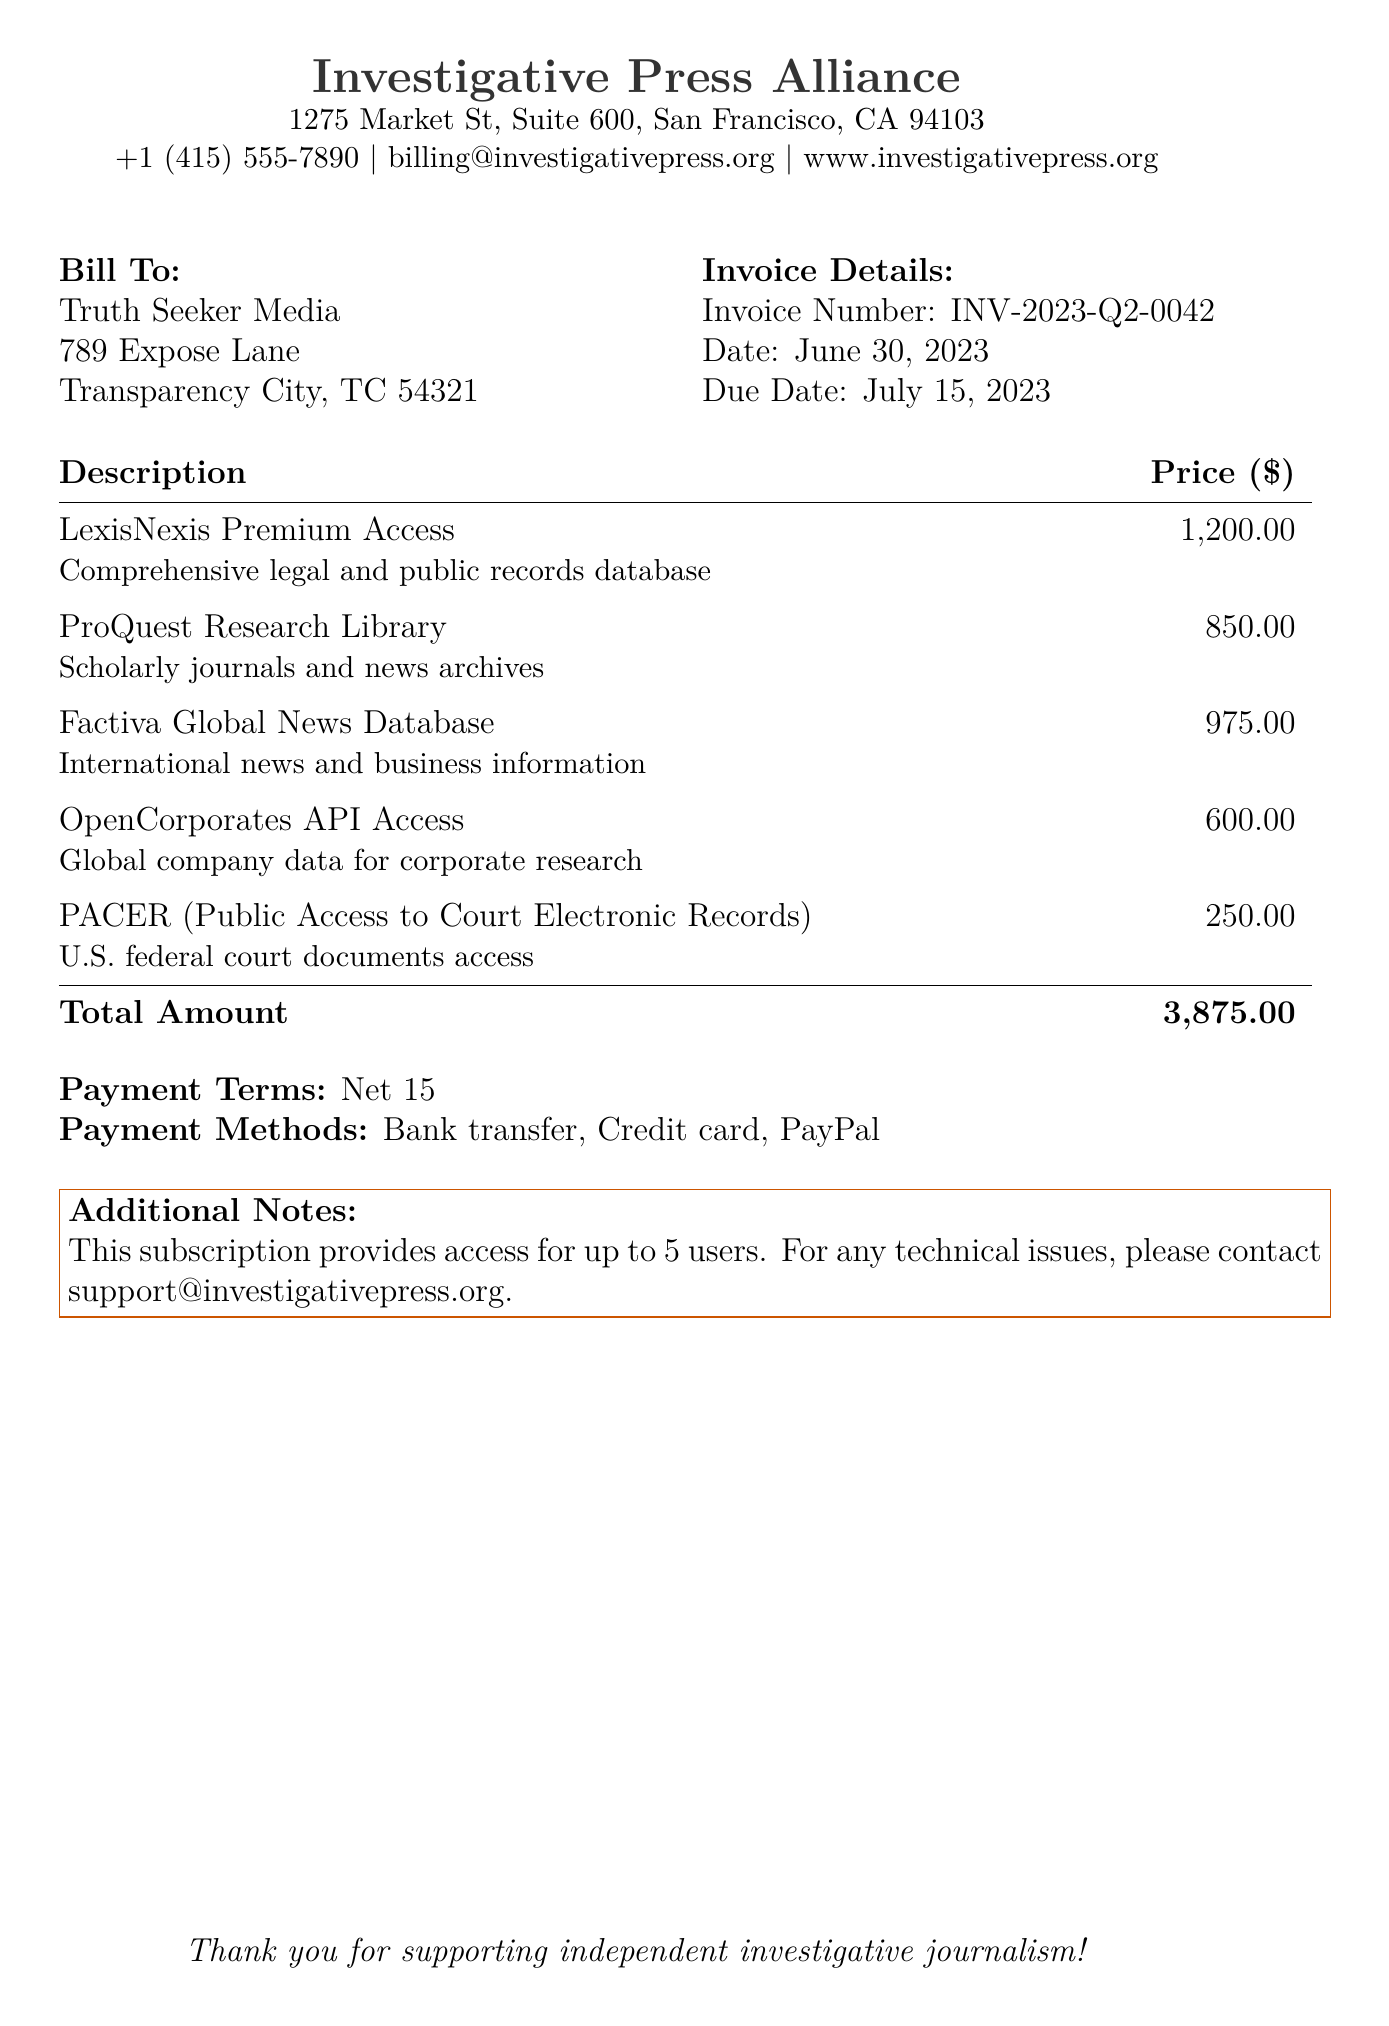What is the total amount due? The total amount due is specified in the invoice as the total of all services listed.
Answer: 3,875.00 What is the invoice number? The invoice number identifies this particular bill for tracking purposes.
Answer: INV-2023-Q2-0042 What is the due date for the payment? The due date indicates when the payment should be made to avoid any penalties.
Answer: July 15, 2023 How many users can access the subscription? This indicates the number of users that can utilize the services provided under this subscription.
Answer: 5 What is the payment term? This specifies the payment condition that must be met.
Answer: Net 15 Which service has the highest price? This identifies the most expensive service listed in the invoice.
Answer: LexisNexis Premium Access What is the price of the OpenCorporates API Access? This directly asks for the price of a specific service included in the invoice.
Answer: 600.00 What payment methods are available? This question asks for the options provided for making the payment.
Answer: Bank transfer, Credit card, PayPal What is the date of the invoice? This indicates when the invoice was created and serves a record-keeping purpose.
Answer: June 30, 2023 